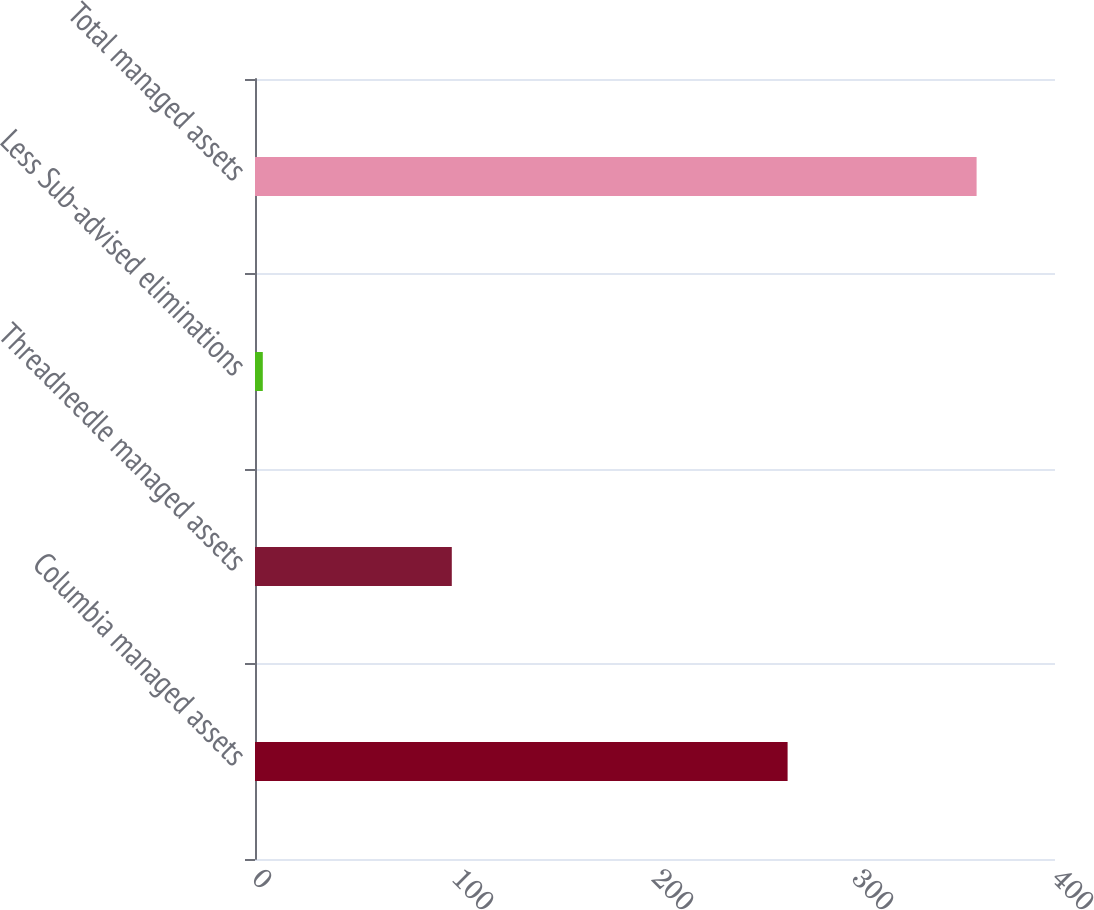Convert chart to OTSL. <chart><loc_0><loc_0><loc_500><loc_500><bar_chart><fcel>Columbia managed assets<fcel>Threadneedle managed assets<fcel>Less Sub-advised eliminations<fcel>Total managed assets<nl><fcel>266.3<fcel>98.4<fcel>3.9<fcel>360.8<nl></chart> 